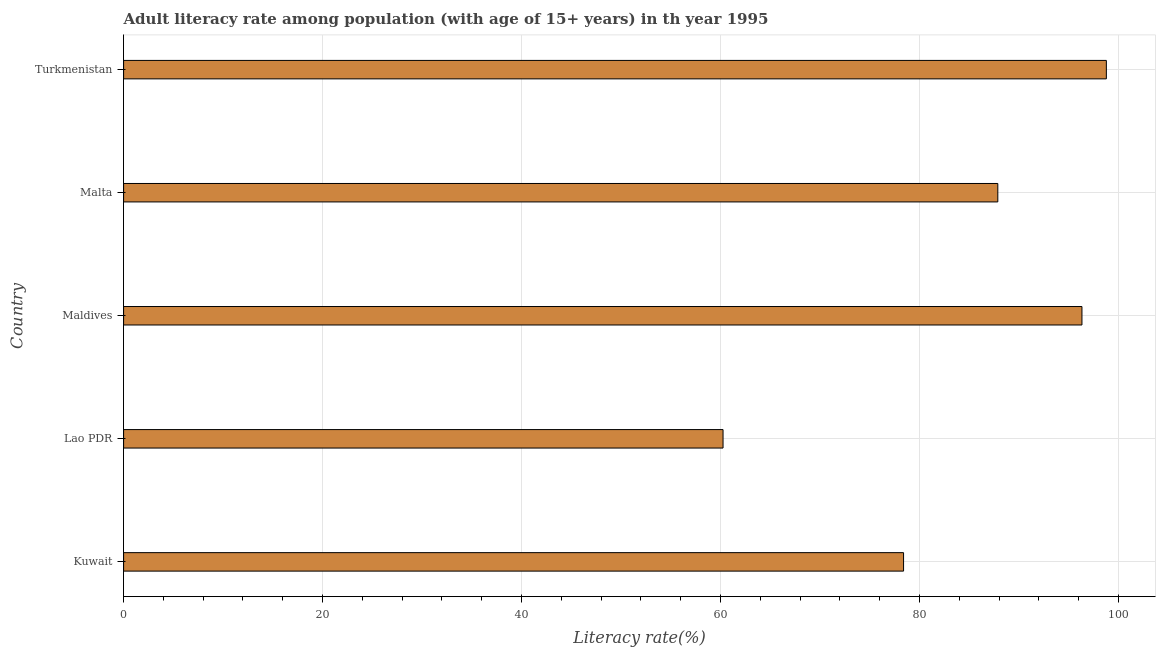What is the title of the graph?
Give a very brief answer. Adult literacy rate among population (with age of 15+ years) in th year 1995. What is the label or title of the X-axis?
Provide a short and direct response. Literacy rate(%). What is the adult literacy rate in Turkmenistan?
Provide a succinct answer. 98.78. Across all countries, what is the maximum adult literacy rate?
Your answer should be very brief. 98.78. Across all countries, what is the minimum adult literacy rate?
Give a very brief answer. 60.25. In which country was the adult literacy rate maximum?
Give a very brief answer. Turkmenistan. In which country was the adult literacy rate minimum?
Your answer should be compact. Lao PDR. What is the sum of the adult literacy rate?
Provide a short and direct response. 421.62. What is the difference between the adult literacy rate in Lao PDR and Turkmenistan?
Keep it short and to the point. -38.53. What is the average adult literacy rate per country?
Your answer should be compact. 84.32. What is the median adult literacy rate?
Offer a very short reply. 87.87. What is the ratio of the adult literacy rate in Kuwait to that in Lao PDR?
Provide a short and direct response. 1.3. Is the difference between the adult literacy rate in Kuwait and Lao PDR greater than the difference between any two countries?
Your answer should be compact. No. What is the difference between the highest and the second highest adult literacy rate?
Your answer should be compact. 2.45. What is the difference between the highest and the lowest adult literacy rate?
Keep it short and to the point. 38.53. Are all the bars in the graph horizontal?
Your response must be concise. Yes. How many countries are there in the graph?
Give a very brief answer. 5. What is the difference between two consecutive major ticks on the X-axis?
Your answer should be compact. 20. Are the values on the major ticks of X-axis written in scientific E-notation?
Ensure brevity in your answer.  No. What is the Literacy rate(%) in Kuwait?
Provide a short and direct response. 78.4. What is the Literacy rate(%) in Lao PDR?
Your response must be concise. 60.25. What is the Literacy rate(%) in Maldives?
Provide a short and direct response. 96.33. What is the Literacy rate(%) in Malta?
Make the answer very short. 87.87. What is the Literacy rate(%) of Turkmenistan?
Provide a short and direct response. 98.78. What is the difference between the Literacy rate(%) in Kuwait and Lao PDR?
Keep it short and to the point. 18.14. What is the difference between the Literacy rate(%) in Kuwait and Maldives?
Give a very brief answer. -17.93. What is the difference between the Literacy rate(%) in Kuwait and Malta?
Offer a very short reply. -9.47. What is the difference between the Literacy rate(%) in Kuwait and Turkmenistan?
Offer a very short reply. -20.38. What is the difference between the Literacy rate(%) in Lao PDR and Maldives?
Make the answer very short. -36.08. What is the difference between the Literacy rate(%) in Lao PDR and Malta?
Your answer should be compact. -27.62. What is the difference between the Literacy rate(%) in Lao PDR and Turkmenistan?
Your answer should be very brief. -38.53. What is the difference between the Literacy rate(%) in Maldives and Malta?
Provide a succinct answer. 8.46. What is the difference between the Literacy rate(%) in Maldives and Turkmenistan?
Ensure brevity in your answer.  -2.45. What is the difference between the Literacy rate(%) in Malta and Turkmenistan?
Provide a short and direct response. -10.91. What is the ratio of the Literacy rate(%) in Kuwait to that in Lao PDR?
Ensure brevity in your answer.  1.3. What is the ratio of the Literacy rate(%) in Kuwait to that in Maldives?
Offer a very short reply. 0.81. What is the ratio of the Literacy rate(%) in Kuwait to that in Malta?
Your answer should be very brief. 0.89. What is the ratio of the Literacy rate(%) in Kuwait to that in Turkmenistan?
Give a very brief answer. 0.79. What is the ratio of the Literacy rate(%) in Lao PDR to that in Malta?
Your response must be concise. 0.69. What is the ratio of the Literacy rate(%) in Lao PDR to that in Turkmenistan?
Keep it short and to the point. 0.61. What is the ratio of the Literacy rate(%) in Maldives to that in Malta?
Your response must be concise. 1.1. What is the ratio of the Literacy rate(%) in Malta to that in Turkmenistan?
Provide a short and direct response. 0.89. 